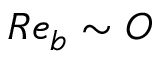Convert formula to latex. <formula><loc_0><loc_0><loc_500><loc_500>R e _ { b } \sim O</formula> 